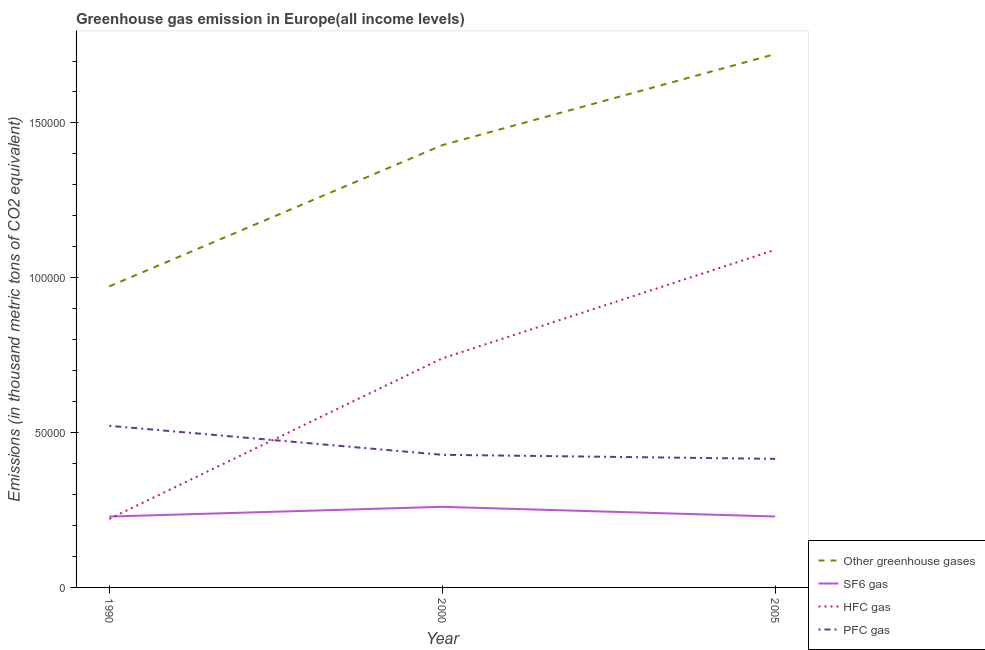Is the number of lines equal to the number of legend labels?
Ensure brevity in your answer.  Yes. What is the emission of hfc gas in 2005?
Keep it short and to the point. 1.09e+05. Across all years, what is the maximum emission of sf6 gas?
Provide a short and direct response. 2.60e+04. Across all years, what is the minimum emission of greenhouse gases?
Your answer should be compact. 9.72e+04. In which year was the emission of greenhouse gases maximum?
Keep it short and to the point. 2005. What is the total emission of greenhouse gases in the graph?
Your answer should be very brief. 4.12e+05. What is the difference between the emission of hfc gas in 1990 and that in 2000?
Provide a succinct answer. -5.18e+04. What is the difference between the emission of hfc gas in 2005 and the emission of pfc gas in 1990?
Keep it short and to the point. 5.68e+04. What is the average emission of hfc gas per year?
Your response must be concise. 6.84e+04. In the year 1990, what is the difference between the emission of sf6 gas and emission of pfc gas?
Make the answer very short. -2.93e+04. In how many years, is the emission of greenhouse gases greater than 110000 thousand metric tons?
Your answer should be compact. 2. What is the ratio of the emission of pfc gas in 2000 to that in 2005?
Offer a terse response. 1.03. What is the difference between the highest and the second highest emission of hfc gas?
Make the answer very short. 3.51e+04. What is the difference between the highest and the lowest emission of greenhouse gases?
Ensure brevity in your answer.  7.50e+04. In how many years, is the emission of pfc gas greater than the average emission of pfc gas taken over all years?
Keep it short and to the point. 1. Is it the case that in every year, the sum of the emission of pfc gas and emission of sf6 gas is greater than the sum of emission of greenhouse gases and emission of hfc gas?
Your answer should be compact. Yes. Is it the case that in every year, the sum of the emission of greenhouse gases and emission of sf6 gas is greater than the emission of hfc gas?
Ensure brevity in your answer.  Yes. Does the emission of sf6 gas monotonically increase over the years?
Ensure brevity in your answer.  No. How many lines are there?
Provide a short and direct response. 4. Are the values on the major ticks of Y-axis written in scientific E-notation?
Your answer should be compact. No. Where does the legend appear in the graph?
Your response must be concise. Bottom right. What is the title of the graph?
Offer a very short reply. Greenhouse gas emission in Europe(all income levels). Does "Germany" appear as one of the legend labels in the graph?
Your answer should be very brief. No. What is the label or title of the Y-axis?
Your response must be concise. Emissions (in thousand metric tons of CO2 equivalent). What is the Emissions (in thousand metric tons of CO2 equivalent) of Other greenhouse gases in 1990?
Ensure brevity in your answer.  9.72e+04. What is the Emissions (in thousand metric tons of CO2 equivalent) in SF6 gas in 1990?
Your answer should be very brief. 2.29e+04. What is the Emissions (in thousand metric tons of CO2 equivalent) of HFC gas in 1990?
Offer a very short reply. 2.21e+04. What is the Emissions (in thousand metric tons of CO2 equivalent) in PFC gas in 1990?
Ensure brevity in your answer.  5.22e+04. What is the Emissions (in thousand metric tons of CO2 equivalent) of Other greenhouse gases in 2000?
Provide a succinct answer. 1.43e+05. What is the Emissions (in thousand metric tons of CO2 equivalent) of SF6 gas in 2000?
Provide a succinct answer. 2.60e+04. What is the Emissions (in thousand metric tons of CO2 equivalent) in HFC gas in 2000?
Offer a terse response. 7.40e+04. What is the Emissions (in thousand metric tons of CO2 equivalent) of PFC gas in 2000?
Provide a succinct answer. 4.28e+04. What is the Emissions (in thousand metric tons of CO2 equivalent) in Other greenhouse gases in 2005?
Your answer should be compact. 1.72e+05. What is the Emissions (in thousand metric tons of CO2 equivalent) of SF6 gas in 2005?
Offer a very short reply. 2.29e+04. What is the Emissions (in thousand metric tons of CO2 equivalent) of HFC gas in 2005?
Offer a terse response. 1.09e+05. What is the Emissions (in thousand metric tons of CO2 equivalent) in PFC gas in 2005?
Provide a short and direct response. 4.15e+04. Across all years, what is the maximum Emissions (in thousand metric tons of CO2 equivalent) of Other greenhouse gases?
Your answer should be very brief. 1.72e+05. Across all years, what is the maximum Emissions (in thousand metric tons of CO2 equivalent) of SF6 gas?
Ensure brevity in your answer.  2.60e+04. Across all years, what is the maximum Emissions (in thousand metric tons of CO2 equivalent) of HFC gas?
Give a very brief answer. 1.09e+05. Across all years, what is the maximum Emissions (in thousand metric tons of CO2 equivalent) in PFC gas?
Your response must be concise. 5.22e+04. Across all years, what is the minimum Emissions (in thousand metric tons of CO2 equivalent) in Other greenhouse gases?
Your answer should be compact. 9.72e+04. Across all years, what is the minimum Emissions (in thousand metric tons of CO2 equivalent) in SF6 gas?
Your response must be concise. 2.29e+04. Across all years, what is the minimum Emissions (in thousand metric tons of CO2 equivalent) of HFC gas?
Your response must be concise. 2.21e+04. Across all years, what is the minimum Emissions (in thousand metric tons of CO2 equivalent) in PFC gas?
Provide a short and direct response. 4.15e+04. What is the total Emissions (in thousand metric tons of CO2 equivalent) in Other greenhouse gases in the graph?
Provide a succinct answer. 4.12e+05. What is the total Emissions (in thousand metric tons of CO2 equivalent) of SF6 gas in the graph?
Offer a very short reply. 7.18e+04. What is the total Emissions (in thousand metric tons of CO2 equivalent) of HFC gas in the graph?
Ensure brevity in your answer.  2.05e+05. What is the total Emissions (in thousand metric tons of CO2 equivalent) in PFC gas in the graph?
Your answer should be very brief. 1.37e+05. What is the difference between the Emissions (in thousand metric tons of CO2 equivalent) of Other greenhouse gases in 1990 and that in 2000?
Your answer should be compact. -4.56e+04. What is the difference between the Emissions (in thousand metric tons of CO2 equivalent) in SF6 gas in 1990 and that in 2000?
Your answer should be compact. -3144.4. What is the difference between the Emissions (in thousand metric tons of CO2 equivalent) of HFC gas in 1990 and that in 2000?
Give a very brief answer. -5.18e+04. What is the difference between the Emissions (in thousand metric tons of CO2 equivalent) in PFC gas in 1990 and that in 2000?
Offer a very short reply. 9372.1. What is the difference between the Emissions (in thousand metric tons of CO2 equivalent) of Other greenhouse gases in 1990 and that in 2005?
Ensure brevity in your answer.  -7.50e+04. What is the difference between the Emissions (in thousand metric tons of CO2 equivalent) in SF6 gas in 1990 and that in 2005?
Keep it short and to the point. -16.51. What is the difference between the Emissions (in thousand metric tons of CO2 equivalent) in HFC gas in 1990 and that in 2005?
Offer a very short reply. -8.69e+04. What is the difference between the Emissions (in thousand metric tons of CO2 equivalent) in PFC gas in 1990 and that in 2005?
Your answer should be very brief. 1.07e+04. What is the difference between the Emissions (in thousand metric tons of CO2 equivalent) of Other greenhouse gases in 2000 and that in 2005?
Offer a very short reply. -2.94e+04. What is the difference between the Emissions (in thousand metric tons of CO2 equivalent) of SF6 gas in 2000 and that in 2005?
Give a very brief answer. 3127.89. What is the difference between the Emissions (in thousand metric tons of CO2 equivalent) in HFC gas in 2000 and that in 2005?
Provide a short and direct response. -3.51e+04. What is the difference between the Emissions (in thousand metric tons of CO2 equivalent) of PFC gas in 2000 and that in 2005?
Offer a terse response. 1308.31. What is the difference between the Emissions (in thousand metric tons of CO2 equivalent) in Other greenhouse gases in 1990 and the Emissions (in thousand metric tons of CO2 equivalent) in SF6 gas in 2000?
Offer a terse response. 7.12e+04. What is the difference between the Emissions (in thousand metric tons of CO2 equivalent) in Other greenhouse gases in 1990 and the Emissions (in thousand metric tons of CO2 equivalent) in HFC gas in 2000?
Make the answer very short. 2.33e+04. What is the difference between the Emissions (in thousand metric tons of CO2 equivalent) in Other greenhouse gases in 1990 and the Emissions (in thousand metric tons of CO2 equivalent) in PFC gas in 2000?
Provide a short and direct response. 5.44e+04. What is the difference between the Emissions (in thousand metric tons of CO2 equivalent) in SF6 gas in 1990 and the Emissions (in thousand metric tons of CO2 equivalent) in HFC gas in 2000?
Ensure brevity in your answer.  -5.11e+04. What is the difference between the Emissions (in thousand metric tons of CO2 equivalent) of SF6 gas in 1990 and the Emissions (in thousand metric tons of CO2 equivalent) of PFC gas in 2000?
Keep it short and to the point. -1.99e+04. What is the difference between the Emissions (in thousand metric tons of CO2 equivalent) in HFC gas in 1990 and the Emissions (in thousand metric tons of CO2 equivalent) in PFC gas in 2000?
Your answer should be very brief. -2.07e+04. What is the difference between the Emissions (in thousand metric tons of CO2 equivalent) in Other greenhouse gases in 1990 and the Emissions (in thousand metric tons of CO2 equivalent) in SF6 gas in 2005?
Offer a very short reply. 7.43e+04. What is the difference between the Emissions (in thousand metric tons of CO2 equivalent) in Other greenhouse gases in 1990 and the Emissions (in thousand metric tons of CO2 equivalent) in HFC gas in 2005?
Your answer should be very brief. -1.18e+04. What is the difference between the Emissions (in thousand metric tons of CO2 equivalent) of Other greenhouse gases in 1990 and the Emissions (in thousand metric tons of CO2 equivalent) of PFC gas in 2005?
Give a very brief answer. 5.57e+04. What is the difference between the Emissions (in thousand metric tons of CO2 equivalent) in SF6 gas in 1990 and the Emissions (in thousand metric tons of CO2 equivalent) in HFC gas in 2005?
Offer a very short reply. -8.61e+04. What is the difference between the Emissions (in thousand metric tons of CO2 equivalent) of SF6 gas in 1990 and the Emissions (in thousand metric tons of CO2 equivalent) of PFC gas in 2005?
Make the answer very short. -1.86e+04. What is the difference between the Emissions (in thousand metric tons of CO2 equivalent) in HFC gas in 1990 and the Emissions (in thousand metric tons of CO2 equivalent) in PFC gas in 2005?
Offer a very short reply. -1.94e+04. What is the difference between the Emissions (in thousand metric tons of CO2 equivalent) in Other greenhouse gases in 2000 and the Emissions (in thousand metric tons of CO2 equivalent) in SF6 gas in 2005?
Offer a terse response. 1.20e+05. What is the difference between the Emissions (in thousand metric tons of CO2 equivalent) of Other greenhouse gases in 2000 and the Emissions (in thousand metric tons of CO2 equivalent) of HFC gas in 2005?
Offer a very short reply. 3.38e+04. What is the difference between the Emissions (in thousand metric tons of CO2 equivalent) of Other greenhouse gases in 2000 and the Emissions (in thousand metric tons of CO2 equivalent) of PFC gas in 2005?
Offer a very short reply. 1.01e+05. What is the difference between the Emissions (in thousand metric tons of CO2 equivalent) of SF6 gas in 2000 and the Emissions (in thousand metric tons of CO2 equivalent) of HFC gas in 2005?
Make the answer very short. -8.30e+04. What is the difference between the Emissions (in thousand metric tons of CO2 equivalent) of SF6 gas in 2000 and the Emissions (in thousand metric tons of CO2 equivalent) of PFC gas in 2005?
Provide a succinct answer. -1.55e+04. What is the difference between the Emissions (in thousand metric tons of CO2 equivalent) in HFC gas in 2000 and the Emissions (in thousand metric tons of CO2 equivalent) in PFC gas in 2005?
Your answer should be very brief. 3.24e+04. What is the average Emissions (in thousand metric tons of CO2 equivalent) in Other greenhouse gases per year?
Offer a terse response. 1.37e+05. What is the average Emissions (in thousand metric tons of CO2 equivalent) of SF6 gas per year?
Your response must be concise. 2.39e+04. What is the average Emissions (in thousand metric tons of CO2 equivalent) in HFC gas per year?
Ensure brevity in your answer.  6.84e+04. What is the average Emissions (in thousand metric tons of CO2 equivalent) of PFC gas per year?
Offer a very short reply. 4.55e+04. In the year 1990, what is the difference between the Emissions (in thousand metric tons of CO2 equivalent) of Other greenhouse gases and Emissions (in thousand metric tons of CO2 equivalent) of SF6 gas?
Keep it short and to the point. 7.43e+04. In the year 1990, what is the difference between the Emissions (in thousand metric tons of CO2 equivalent) in Other greenhouse gases and Emissions (in thousand metric tons of CO2 equivalent) in HFC gas?
Provide a short and direct response. 7.51e+04. In the year 1990, what is the difference between the Emissions (in thousand metric tons of CO2 equivalent) in Other greenhouse gases and Emissions (in thousand metric tons of CO2 equivalent) in PFC gas?
Make the answer very short. 4.50e+04. In the year 1990, what is the difference between the Emissions (in thousand metric tons of CO2 equivalent) of SF6 gas and Emissions (in thousand metric tons of CO2 equivalent) of HFC gas?
Provide a short and direct response. 737.6. In the year 1990, what is the difference between the Emissions (in thousand metric tons of CO2 equivalent) in SF6 gas and Emissions (in thousand metric tons of CO2 equivalent) in PFC gas?
Provide a short and direct response. -2.93e+04. In the year 1990, what is the difference between the Emissions (in thousand metric tons of CO2 equivalent) in HFC gas and Emissions (in thousand metric tons of CO2 equivalent) in PFC gas?
Your response must be concise. -3.01e+04. In the year 2000, what is the difference between the Emissions (in thousand metric tons of CO2 equivalent) in Other greenhouse gases and Emissions (in thousand metric tons of CO2 equivalent) in SF6 gas?
Keep it short and to the point. 1.17e+05. In the year 2000, what is the difference between the Emissions (in thousand metric tons of CO2 equivalent) of Other greenhouse gases and Emissions (in thousand metric tons of CO2 equivalent) of HFC gas?
Offer a terse response. 6.89e+04. In the year 2000, what is the difference between the Emissions (in thousand metric tons of CO2 equivalent) of Other greenhouse gases and Emissions (in thousand metric tons of CO2 equivalent) of PFC gas?
Ensure brevity in your answer.  1.00e+05. In the year 2000, what is the difference between the Emissions (in thousand metric tons of CO2 equivalent) in SF6 gas and Emissions (in thousand metric tons of CO2 equivalent) in HFC gas?
Offer a very short reply. -4.79e+04. In the year 2000, what is the difference between the Emissions (in thousand metric tons of CO2 equivalent) in SF6 gas and Emissions (in thousand metric tons of CO2 equivalent) in PFC gas?
Your response must be concise. -1.68e+04. In the year 2000, what is the difference between the Emissions (in thousand metric tons of CO2 equivalent) of HFC gas and Emissions (in thousand metric tons of CO2 equivalent) of PFC gas?
Provide a succinct answer. 3.11e+04. In the year 2005, what is the difference between the Emissions (in thousand metric tons of CO2 equivalent) of Other greenhouse gases and Emissions (in thousand metric tons of CO2 equivalent) of SF6 gas?
Ensure brevity in your answer.  1.49e+05. In the year 2005, what is the difference between the Emissions (in thousand metric tons of CO2 equivalent) of Other greenhouse gases and Emissions (in thousand metric tons of CO2 equivalent) of HFC gas?
Your answer should be very brief. 6.32e+04. In the year 2005, what is the difference between the Emissions (in thousand metric tons of CO2 equivalent) in Other greenhouse gases and Emissions (in thousand metric tons of CO2 equivalent) in PFC gas?
Your answer should be very brief. 1.31e+05. In the year 2005, what is the difference between the Emissions (in thousand metric tons of CO2 equivalent) in SF6 gas and Emissions (in thousand metric tons of CO2 equivalent) in HFC gas?
Keep it short and to the point. -8.61e+04. In the year 2005, what is the difference between the Emissions (in thousand metric tons of CO2 equivalent) of SF6 gas and Emissions (in thousand metric tons of CO2 equivalent) of PFC gas?
Provide a succinct answer. -1.86e+04. In the year 2005, what is the difference between the Emissions (in thousand metric tons of CO2 equivalent) in HFC gas and Emissions (in thousand metric tons of CO2 equivalent) in PFC gas?
Your response must be concise. 6.75e+04. What is the ratio of the Emissions (in thousand metric tons of CO2 equivalent) of Other greenhouse gases in 1990 to that in 2000?
Provide a short and direct response. 0.68. What is the ratio of the Emissions (in thousand metric tons of CO2 equivalent) in SF6 gas in 1990 to that in 2000?
Make the answer very short. 0.88. What is the ratio of the Emissions (in thousand metric tons of CO2 equivalent) of HFC gas in 1990 to that in 2000?
Your response must be concise. 0.3. What is the ratio of the Emissions (in thousand metric tons of CO2 equivalent) of PFC gas in 1990 to that in 2000?
Give a very brief answer. 1.22. What is the ratio of the Emissions (in thousand metric tons of CO2 equivalent) of Other greenhouse gases in 1990 to that in 2005?
Give a very brief answer. 0.56. What is the ratio of the Emissions (in thousand metric tons of CO2 equivalent) of SF6 gas in 1990 to that in 2005?
Keep it short and to the point. 1. What is the ratio of the Emissions (in thousand metric tons of CO2 equivalent) of HFC gas in 1990 to that in 2005?
Your answer should be compact. 0.2. What is the ratio of the Emissions (in thousand metric tons of CO2 equivalent) in PFC gas in 1990 to that in 2005?
Your answer should be compact. 1.26. What is the ratio of the Emissions (in thousand metric tons of CO2 equivalent) of Other greenhouse gases in 2000 to that in 2005?
Your answer should be compact. 0.83. What is the ratio of the Emissions (in thousand metric tons of CO2 equivalent) in SF6 gas in 2000 to that in 2005?
Provide a succinct answer. 1.14. What is the ratio of the Emissions (in thousand metric tons of CO2 equivalent) in HFC gas in 2000 to that in 2005?
Keep it short and to the point. 0.68. What is the ratio of the Emissions (in thousand metric tons of CO2 equivalent) in PFC gas in 2000 to that in 2005?
Ensure brevity in your answer.  1.03. What is the difference between the highest and the second highest Emissions (in thousand metric tons of CO2 equivalent) in Other greenhouse gases?
Keep it short and to the point. 2.94e+04. What is the difference between the highest and the second highest Emissions (in thousand metric tons of CO2 equivalent) of SF6 gas?
Provide a short and direct response. 3127.89. What is the difference between the highest and the second highest Emissions (in thousand metric tons of CO2 equivalent) of HFC gas?
Offer a terse response. 3.51e+04. What is the difference between the highest and the second highest Emissions (in thousand metric tons of CO2 equivalent) in PFC gas?
Provide a succinct answer. 9372.1. What is the difference between the highest and the lowest Emissions (in thousand metric tons of CO2 equivalent) of Other greenhouse gases?
Give a very brief answer. 7.50e+04. What is the difference between the highest and the lowest Emissions (in thousand metric tons of CO2 equivalent) in SF6 gas?
Make the answer very short. 3144.4. What is the difference between the highest and the lowest Emissions (in thousand metric tons of CO2 equivalent) in HFC gas?
Make the answer very short. 8.69e+04. What is the difference between the highest and the lowest Emissions (in thousand metric tons of CO2 equivalent) of PFC gas?
Your answer should be very brief. 1.07e+04. 